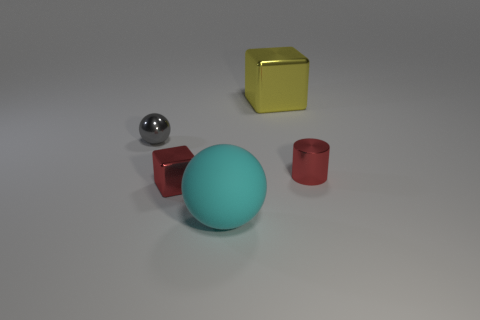Are there more large cyan balls that are to the left of the metal cylinder than small shiny blocks?
Keep it short and to the point. No. What is the material of the thing that is both to the right of the rubber object and in front of the small gray metallic object?
Give a very brief answer. Metal. Is there any other thing that has the same shape as the cyan matte object?
Your answer should be compact. Yes. What number of objects are in front of the tiny red metallic cylinder and on the right side of the small metal cube?
Provide a short and direct response. 1. What is the cyan sphere made of?
Your response must be concise. Rubber. Are there an equal number of balls in front of the big cyan object and big cubes?
Keep it short and to the point. No. How many other small things have the same shape as the gray object?
Your answer should be very brief. 0. Is the yellow thing the same shape as the matte object?
Offer a very short reply. No. How many things are tiny metallic things that are on the right side of the big sphere or red cylinders?
Provide a succinct answer. 1. What shape is the small red shiny object to the right of the cube that is behind the sphere on the left side of the big cyan matte object?
Keep it short and to the point. Cylinder. 